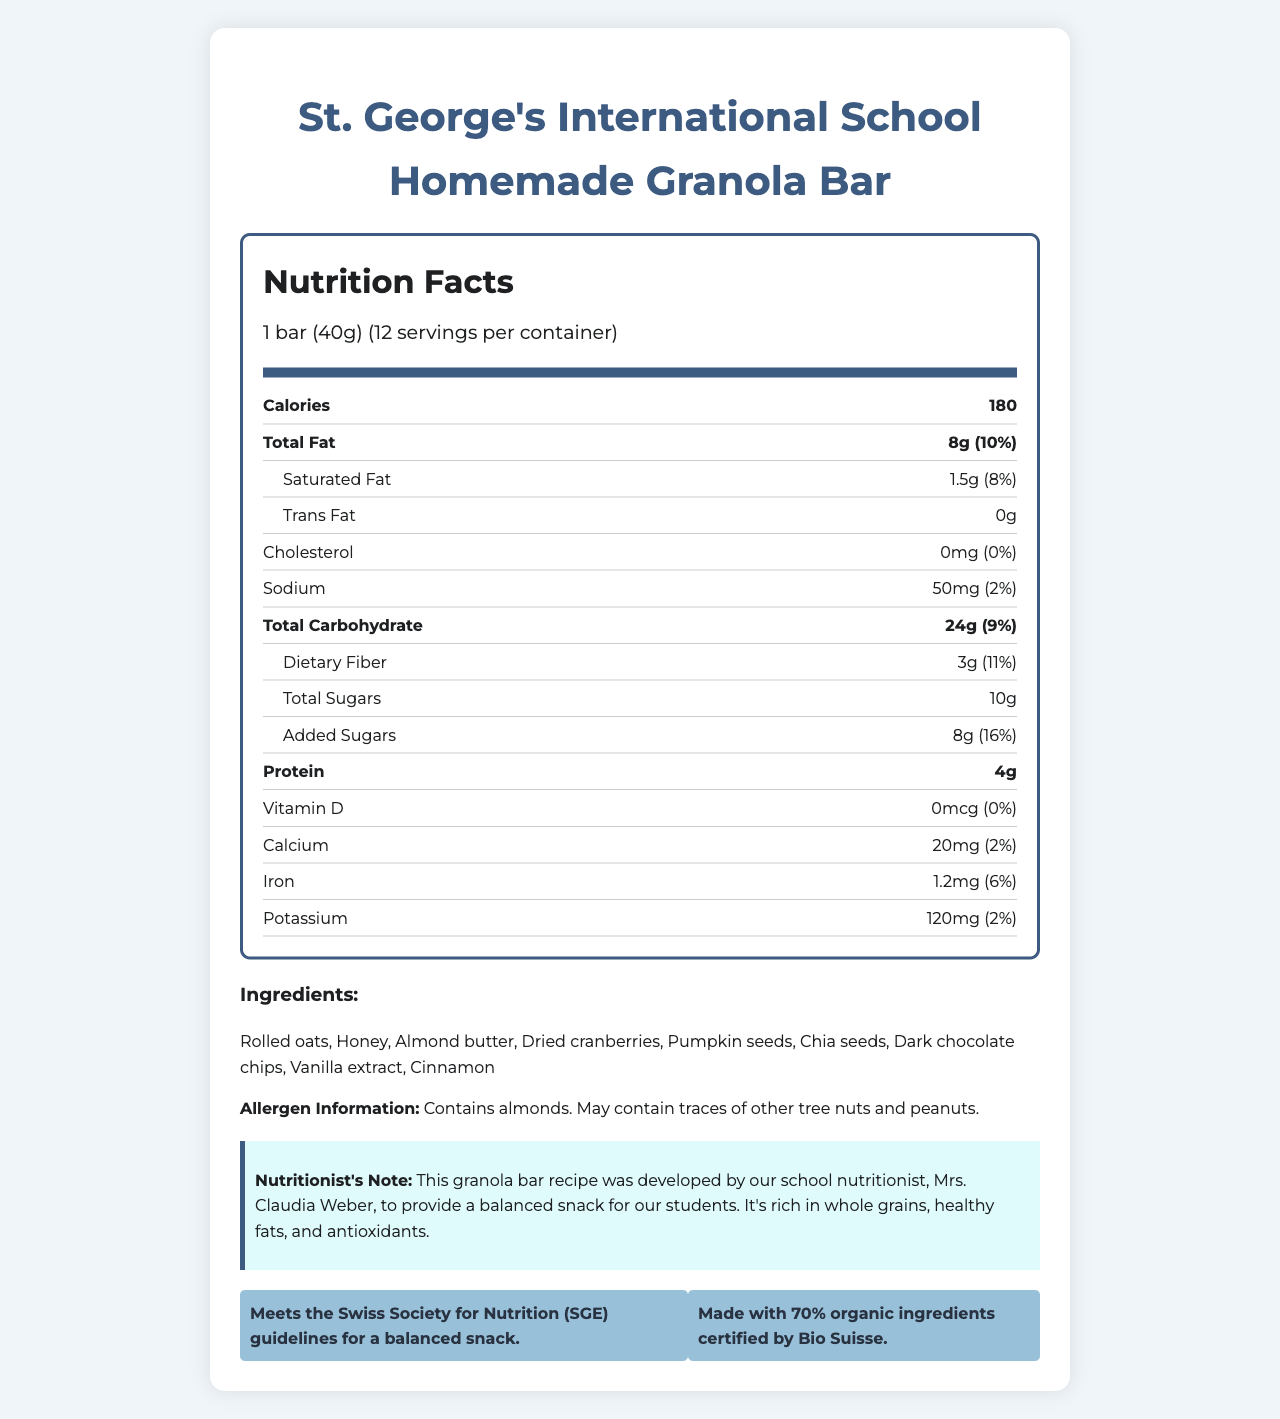what is the serving size of the granola bar? The serving size is explicitly stated as "1 bar (40g)" in the document.
Answer: 1 bar (40g) how many calories are there per serving? The document specifies there are 180 calories per serving.
Answer: 180 what is the total amount of fat in one granola bar? The total fat content per bar is listed as 8g.
Answer: 8g what percentage of the daily value is the dietary fiber content? The dietary fiber content has a percent daily value of 11%, as per the document.
Answer: 11% what is the source of added sugars in the ingredients? According to the ingredient list, honey is likely the source of added sugars.
Answer: Honey which ingredient provides protein in the granola bar? A. Dried cranberries B. Almond butter C. Cinnamon D. Dark chocolate chips Almond butter is a source of protein, as indicated in the document.
Answer: B. Almond butter what certification does this granola bar meet? A. USDA Organic B. Bio Suisse Organic C. European Organic The document states that the granola bar is made with ingredients certified by Bio Suisse.
Answer: B. Bio Suisse Organic how much potassium is in one serving of the granola bar? The potassium content is listed as 120mg per serving.
Answer: 120mg is this granola bar suitable for someone with a peanut allergy? The allergen information indicates it may contain traces of peanuts, making it unsuitable for someone with a peanut allergy.
Answer: No describe the nutritional profile and certifications of the homemade granola bar. The bar provides a balanced snack option with a good mix of fats, proteins, and carbohydrates, along with adequate fiber. It meets the Swiss Society for Nutrition guidelines and is made with mostly organic ingredients.
Answer: The granola bar provides balanced nutrition with 180 calories, 8g total fat, 4g protein, and 3g dietary fiber per serving. It meets Swiss health standards and contains 70% organic ingredients, certified by Bio Suisse. who developed the granola bar recipe? The document states that the recipe was developed by Mrs. Claudia Weber, the school nutritionist at St. George's International School.
Answer: Mrs. Claudia Weber, the school nutritionist how much iron is there in one serving of the granola bar? One serving of the granola bar contains 1.2mg of iron.
Answer: 1.2mg what percentage of the granola bar's ingredients are organic? The document specifies that 70% of the ingredients are organic.
Answer: 70% how many servings are there in the container? According to the document, there are 12 servings per container.
Answer: 12 are there any artificial ingredients in the granola bar? The listed ingredients such as rolled oats, honey, almond butter, and others are all natural, suggesting no artificial ingredients.
Answer: No are there peanuts in the ingredient list? Peanuts are not listed in the ingredient list, but the bars may contain traces of peanuts.
Answer: No what is the main idea of the document? The main idea is to inform parents about the nutritional content and benefits of the homemade granola bar, emphasizing its balanced ingredients and health certifications.
Answer: The document provides the nutritional facts and ingredient information for a homemade granola bar recipe designed by the school's nutritionist. It highlights the bar's balanced nutritional content, allergen information, and compliance with health standards. what specific antioxidant-rich ingredient is mentioned? The document mentions that dried cranberries, which are known to be rich in antioxidants, are an ingredient.
Answer: Dried cranberries what is not stated about the bar in the document: A. Protein content B. Vitamin C content C. Allergen information The document mentions the protein content and allergen information, but it does not provide information on the vitamin C content.
Answer: B. Vitamin C content 